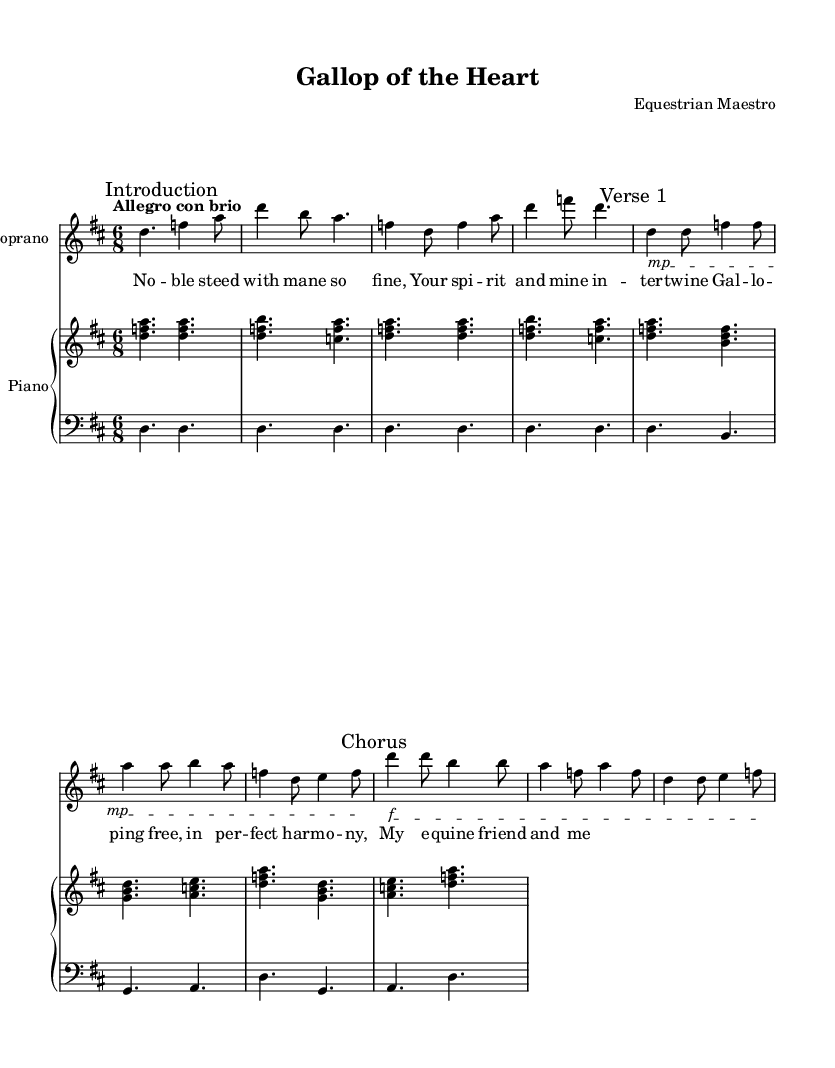What is the key signature of this music? The key signature is found at the beginning of the staff. In this case, it has two sharps (F# and C#), which indicates that the key is D major.
Answer: D major What is the time signature of the piece? The time signature is located at the beginning of the sheet music. It shows that there are six eighth notes per measure, which is represented as 6/8.
Answer: 6/8 What is the tempo marking found in the music? The tempo marking is provided in Italian at the start, indicating the speed of the piece. Here it states "Allegro con brio," which suggests a lively tempo with vigor.
Answer: Allegro con brio How many measures are in the introduction? To find the number of measures in the introduction, count each distinct set of bar lines. There are four measures present in this section of the piece.
Answer: 4 What is the dynamic marking for the Chorus section? The dynamic marking can be found before the Chorus, where it states "f" indicating a "forte" or loud dynamic.
Answer: f How does the upper voice relate to the lower voice throughout the piece? By analyzing the structure, the upper voice plays harmony and embellishments, while the lower voice maintains the bass line, thus complementing the soprano's melody. This relationship supports the overall harmonic foundation of the aria.
Answer: Complementary 